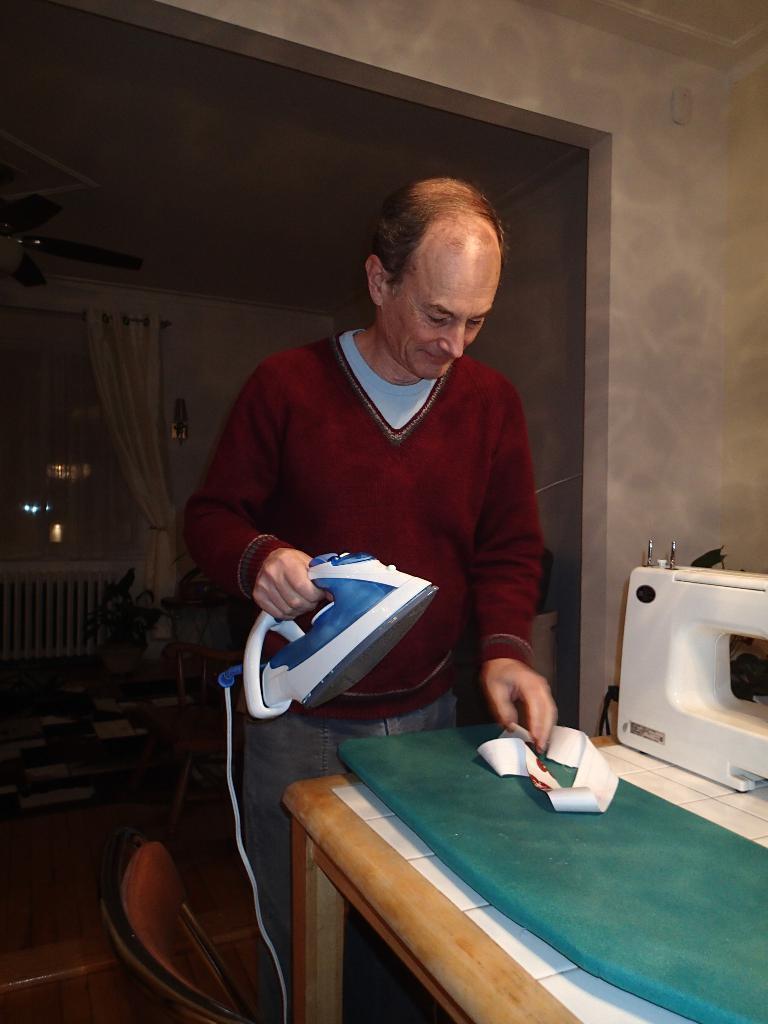Please provide a concise description of this image. As we can see in the image there is a wall, curtain, window, table, sewing machine and a person holding iron box. 